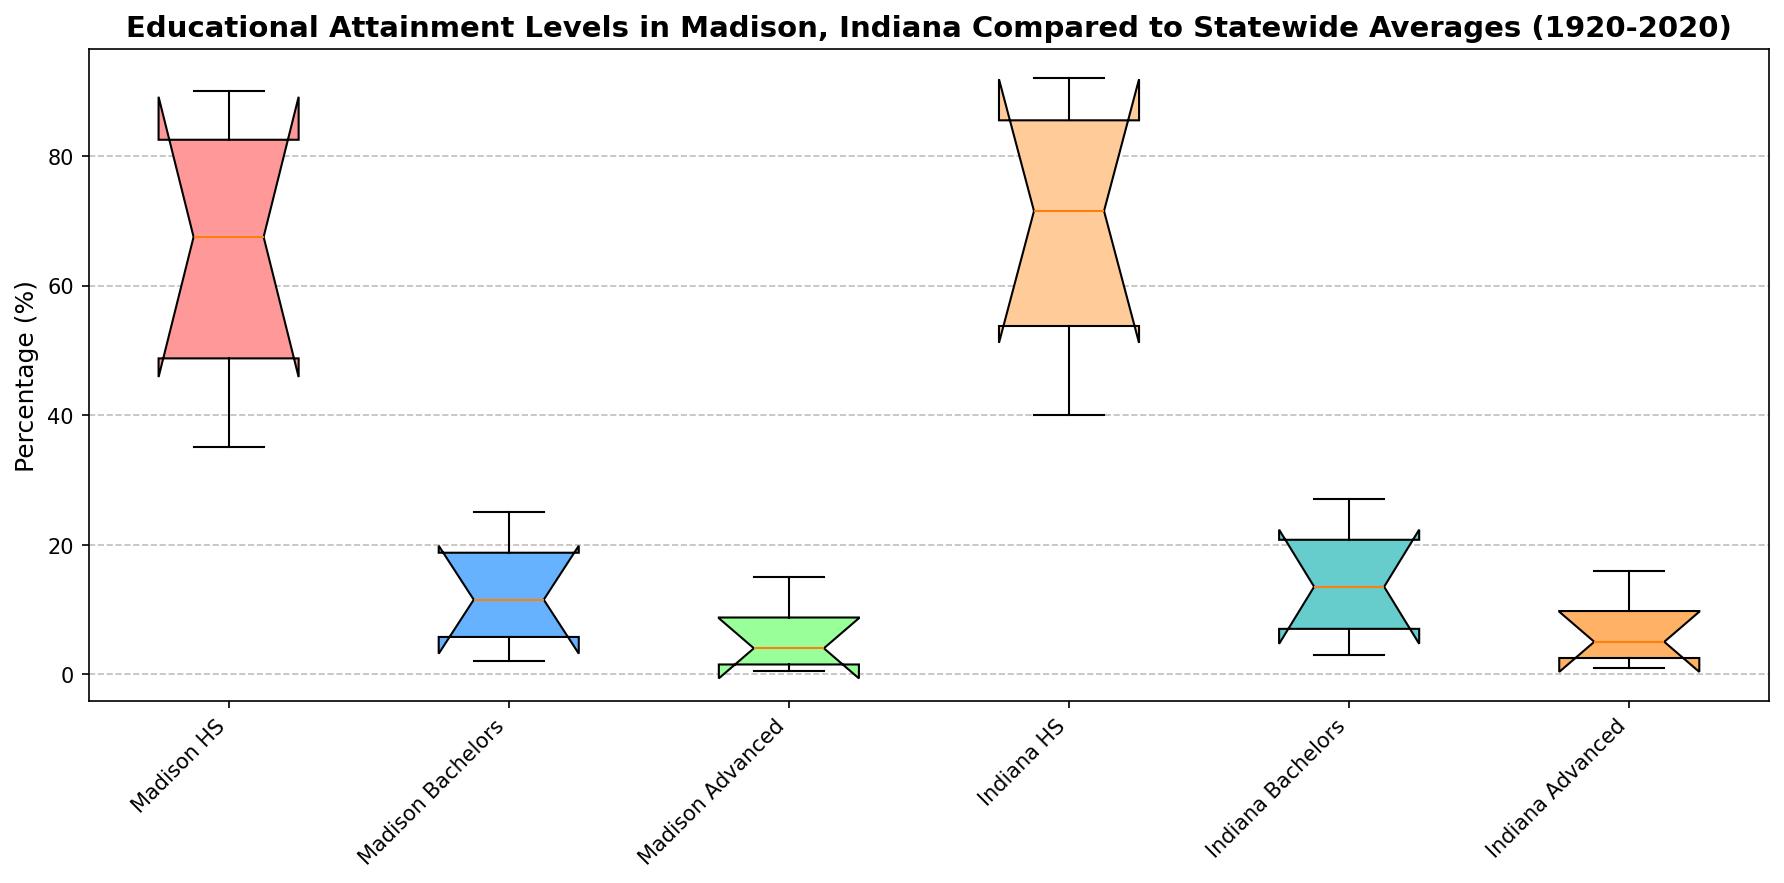What is the median percentage of High School Graduates in Madison? From the boxplot, locate the box representing Madison HS. The line inside the box represents the median value.
Answer: 75 Which location has a higher median percentage of Bachelor’s Degree holders? Compare the median lines in the Madison Bachelors and Indiana Bachelors boxes. The higher line indicates the higher median percentage.
Answer: Indiana Between Madison and Indiana, which location shows a greater variation in percentages of Advanced Degree holders? Look at the spread (Range from the bottom to the top whisker) of the Advanced Degree boxes for both Madison and Indiana. The wider spread indicates greater variation.
Answer: Indiana What is the approximate difference in median percentages of Advanced Degrees between Madison and Indiana? Identify the median percentages (lines inside the boxes) of the Madison Advanced and Indiana Advanced categories and calculate the difference.
Answer: 1 Which educational attainment category shows the most improvement over the past century in Madison? Compare the lower and upper whiskers of the Madison HS, Madison Bachelors, and Madison Advanced boxes to see which has the greatest vertical distance.
Answer: High School Graduates Which educational attainment category in Indiana has the least spread? Compare the length of the boxes and whiskers for Indiana HS, Indiana Bachelors, and Indiana Advanced categories. The smallest box and whiskers correspond to the least spread.
Answer: High_School_Graduate How do the median percentages of High School Graduates in Madison compare to Indiana over the time period? Look at the median lines inside the boxes labeled Madison HS and Indiana HS, and note how they compare in height.
Answer: Lower in Madison Is there an educational attainment category where Madison and Indiana have nearly equal median percentages? Compare the median lines across the different categories. The closest medians are the most similar.
Answer: Advanced Degree Which educational attainment category has the smallest increase over the century in Madison? Look at the positions of the whiskers at the bottom and top of the Madison boxes. The category with the smallest difference is the smallest increase.
Answer: Advanced Degree What can be inferred about the trends in educational attainment in Madison over the last century compared to Indiana? Assess all the boxes and whiskers for both Madison and Indiana, focusing on shifts in medians and spreads to comprehend trends.
Answer: Madison generally has lower percentages and greater variations compared to Indiana 